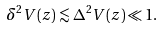Convert formula to latex. <formula><loc_0><loc_0><loc_500><loc_500>\delta ^ { 2 } V ( z ) \lesssim \Delta ^ { 2 } V ( z ) \ll 1 .</formula> 